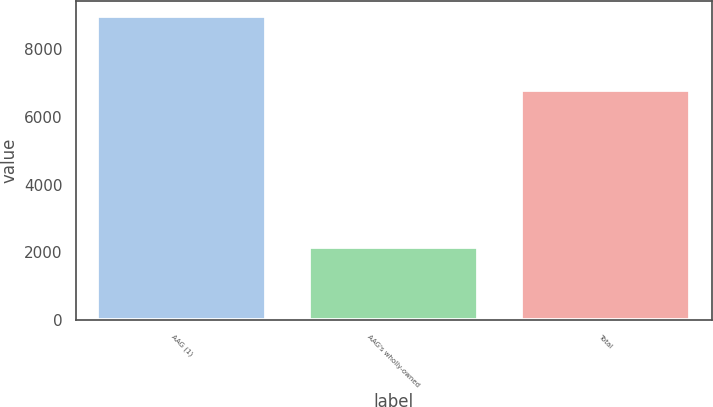Convert chart. <chart><loc_0><loc_0><loc_500><loc_500><bar_chart><fcel>AAG (1)<fcel>AAG's wholly-owned<fcel>Total<nl><fcel>8981<fcel>2171<fcel>6810<nl></chart> 